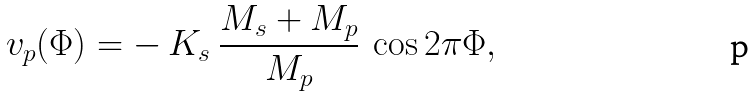Convert formula to latex. <formula><loc_0><loc_0><loc_500><loc_500>v _ { p } ( \Phi ) = - \ K _ { s } \ \frac { M _ { s } + M _ { p } } { M _ { p } } \ \cos { 2 \pi \Phi } ,</formula> 